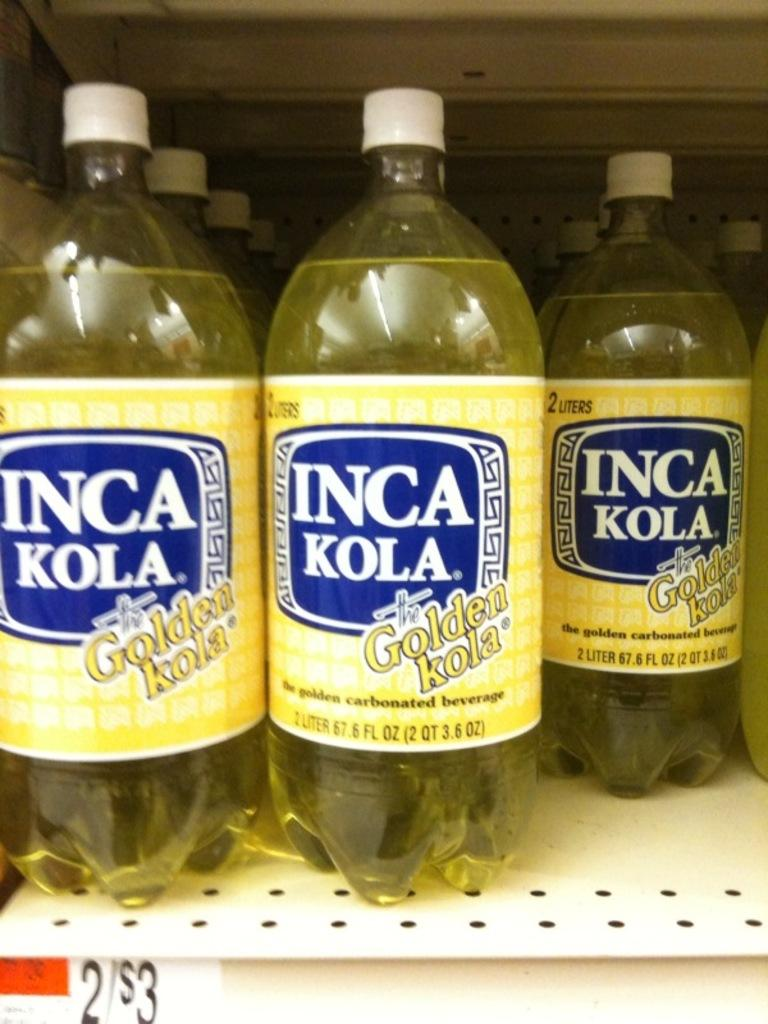What objects are visible in the image? There are bottles in the image. Where are the bottles located? The bottles are placed on shelves. How many slaves are depicted in the image? There are no slaves present in the image; it only features bottles on shelves. What type of beetle can be seen crawling on the bottles in the image? There are no beetles present in the image; it only features bottles on shelves. 